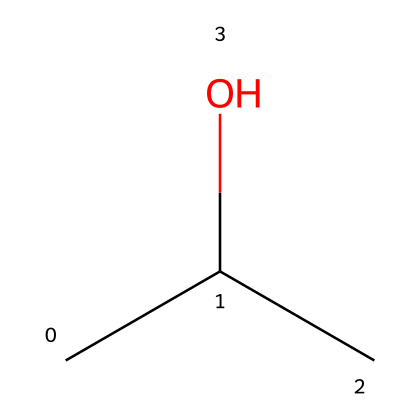How many carbon atoms are in isopropyl alcohol? In the SMILES representation "CC(C)O", there are three 'C' characters, which correspond to three carbon atoms.
Answer: 3 What functional group is present in isopropyl alcohol? The 'O' in the SMILES representation indicates the presence of a hydroxyl (-OH) functional group, which characterizes alcohols.
Answer: hydroxyl How many hydrogen atoms are in isopropyl alcohol? Each carbon atom can form four bonds. The structure shows three carbon atoms connected to hydrogens and a hydroxyl group, leading to a total of eight hydrogen atoms.
Answer: 8 Is isopropyl alcohol a flammable liquid? Yes, isopropyl alcohol is classified as a flammable liquid due to its ability to ignite under standard conditions.
Answer: Yes Why is isopropyl alcohol useful in first aid kits? Isopropyl alcohol serves as an antiseptic due to its antimicrobial properties, allowing it to disinfect wounds and surfaces effectively.
Answer: antiseptic What type of bonding is primarily present in isopropyl alcohol? The bonding in isopropyl alcohol primarily includes covalent bonds between carbon, hydrogen, and oxygen atoms.
Answer: covalent bonds What would be the risk if isopropyl alcohol is improperly stored? Improper storage can lead to a fire hazard, given that isopropyl alcohol is flammable and can easily ignite if exposed to an open flame or spark.
Answer: fire hazard 